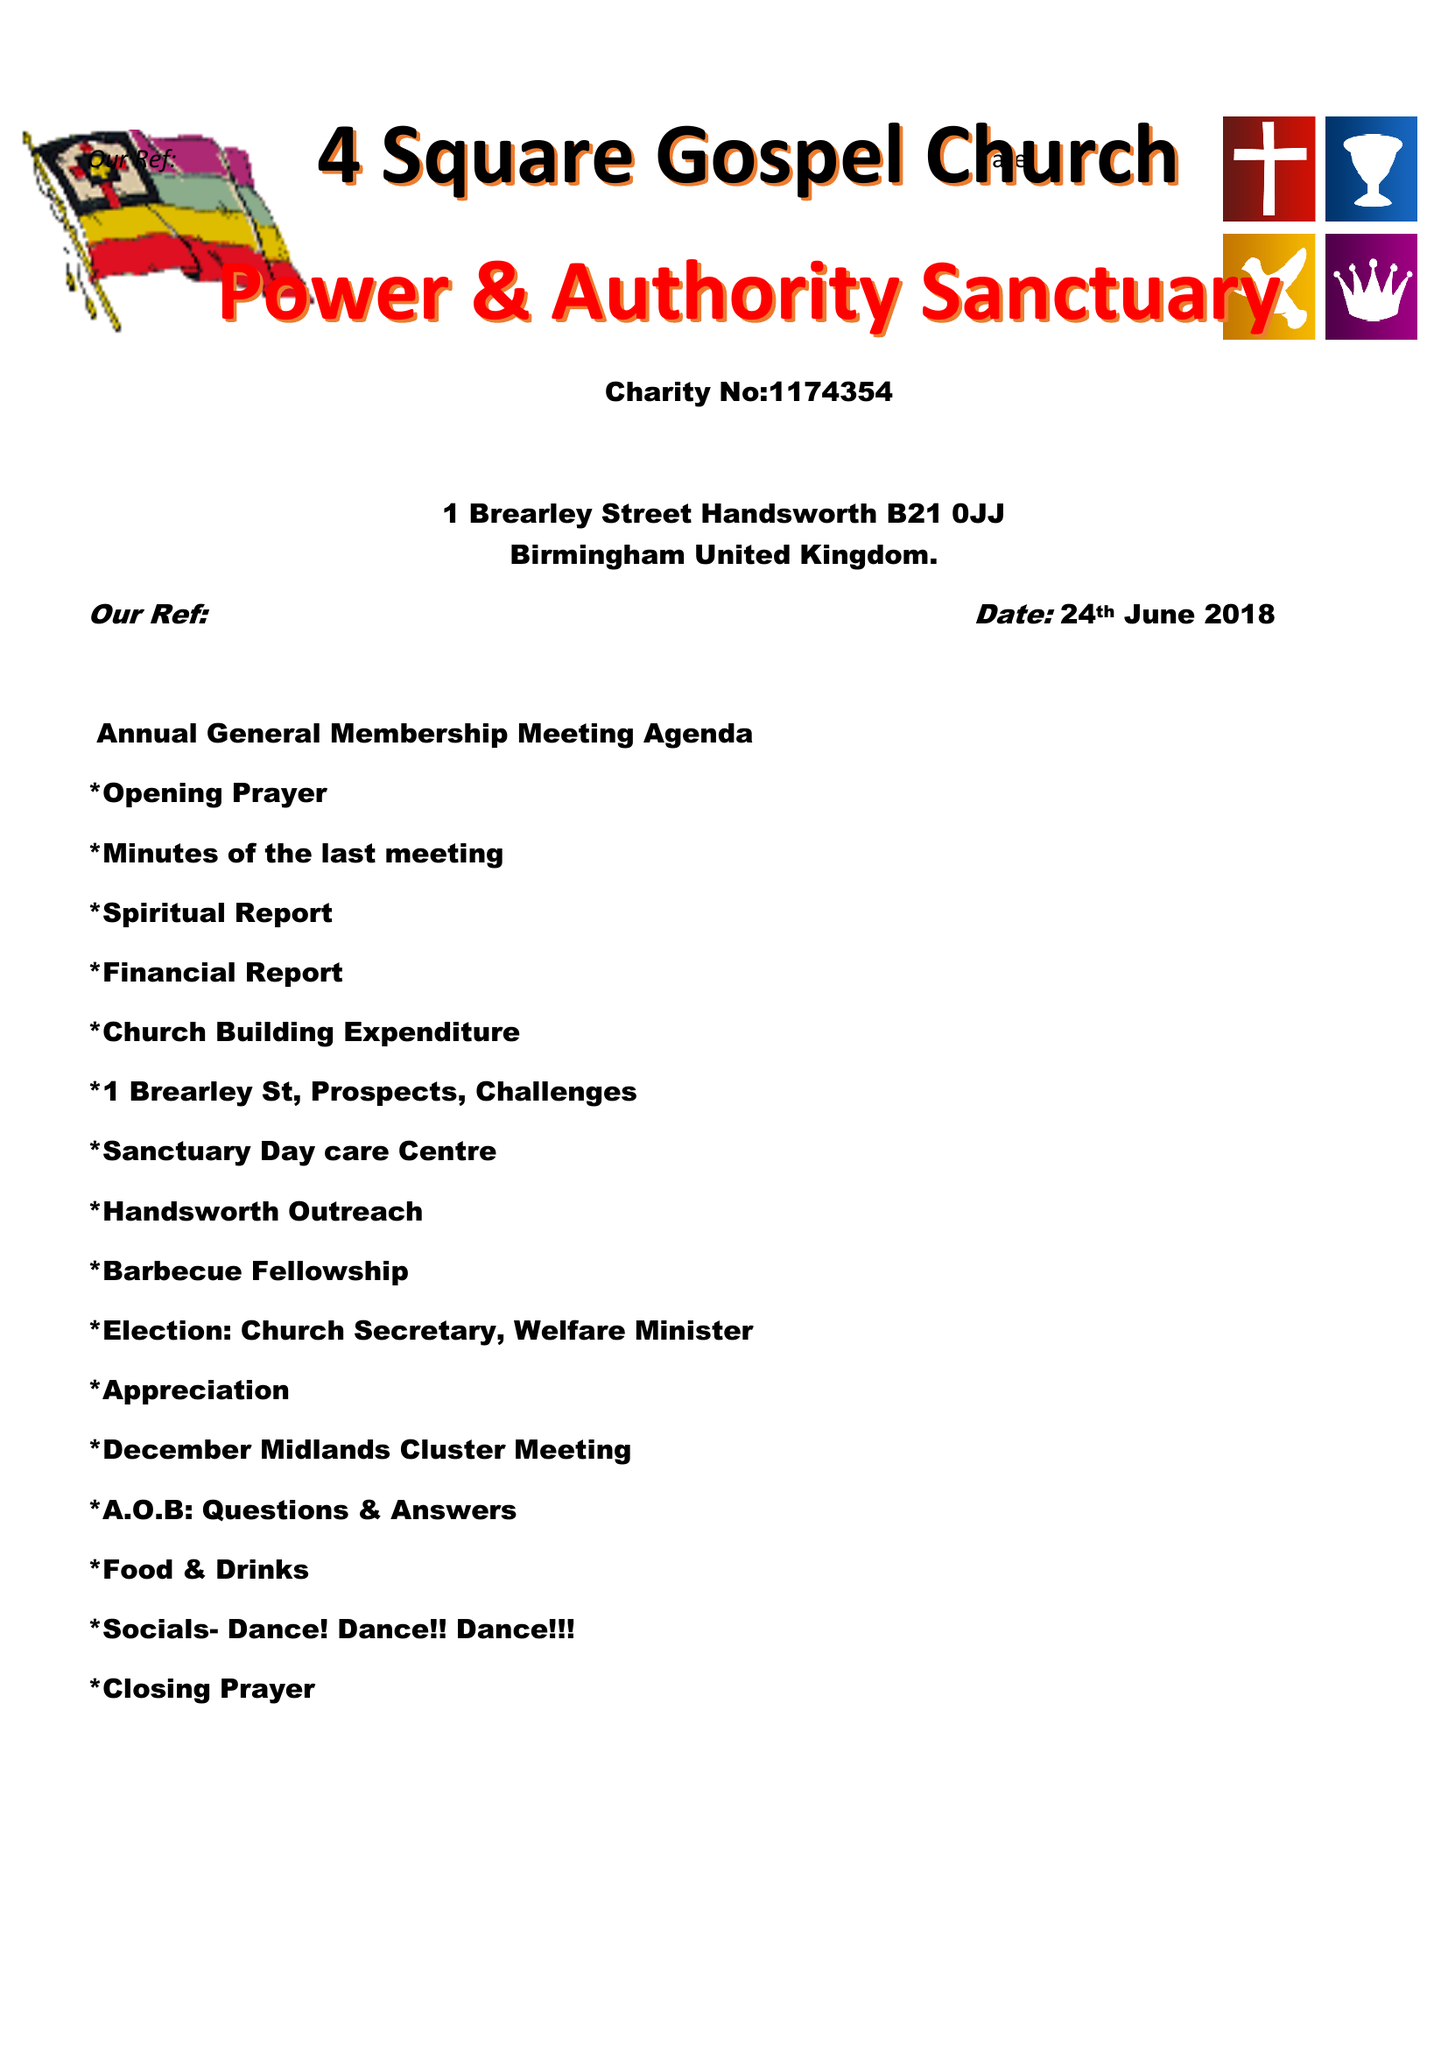What is the value for the charity_name?
Answer the question using a single word or phrase. 4 Square Gospel Church, Power and Authority Sanctuary 